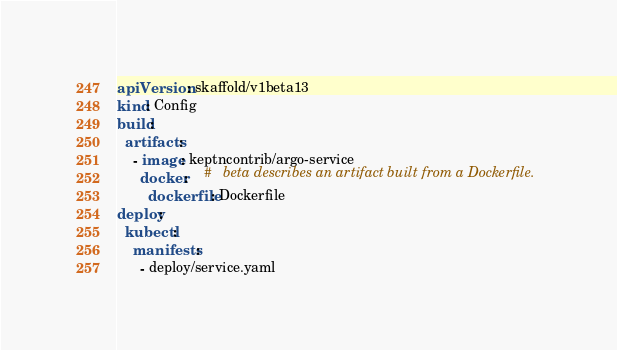<code> <loc_0><loc_0><loc_500><loc_500><_YAML_>apiVersion: skaffold/v1beta13
kind: Config
build:
  artifacts:
    - image: keptncontrib/argo-service
      docker:    # 	beta describes an artifact built from a Dockerfile.
        dockerfile: Dockerfile
deploy:
  kubectl:
    manifests:
      - deploy/service.yaml
</code> 